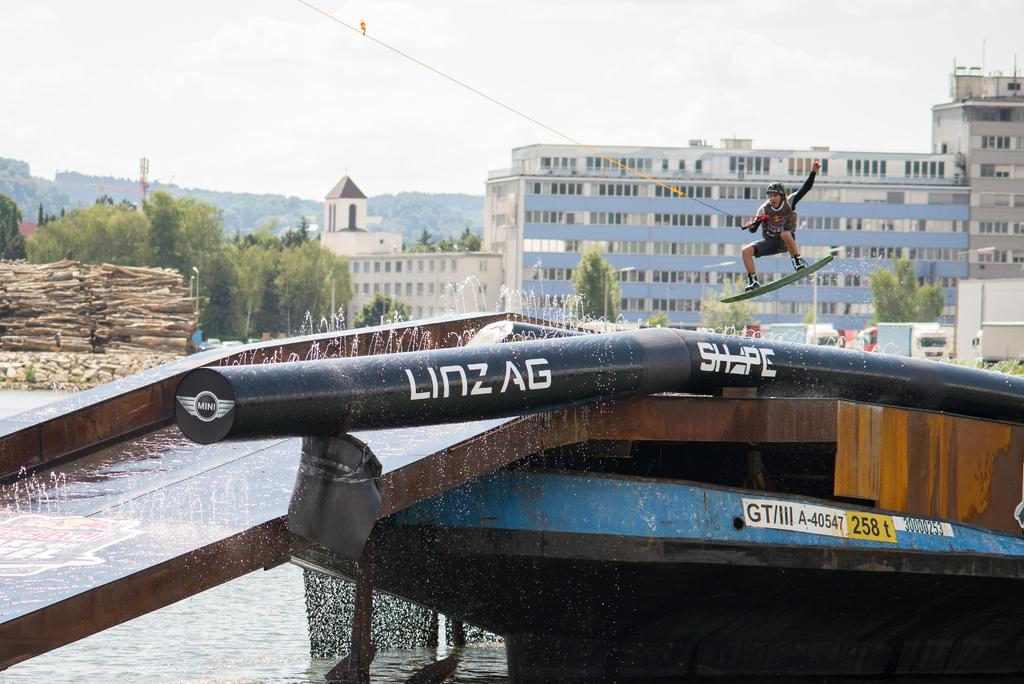<image>
Present a compact description of the photo's key features. A bar that has lettering on it that reads LINZ AG. 